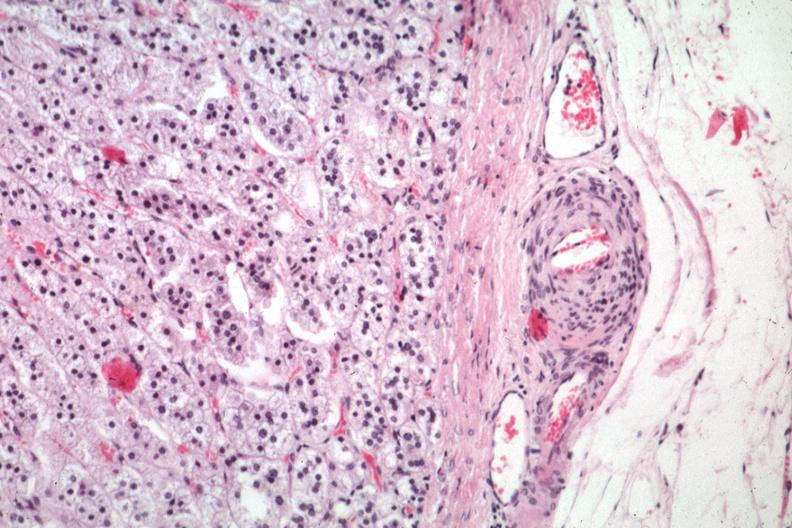does chromophobe adenoma show typical lesion in small artery just outside capsule?
Answer the question using a single word or phrase. No 